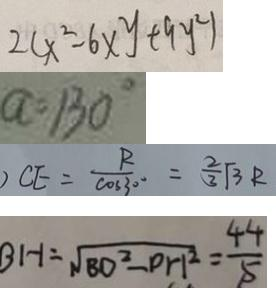Convert formula to latex. <formula><loc_0><loc_0><loc_500><loc_500>2 ( x ^ { 2 } - 6 x y + 9 y ^ { 2 } ) 
 a = 1 3 0 ^ { \circ } 
 ) C E = \frac { R } { \cos 3 0 ^ { \circ } } = \frac { 2 } { 3 } \sqrt { 3 } R 
 B H = \sqrt { B O ^ { 2 } - P H ^ { 2 } } = \frac { 4 4 } { 5 }</formula> 